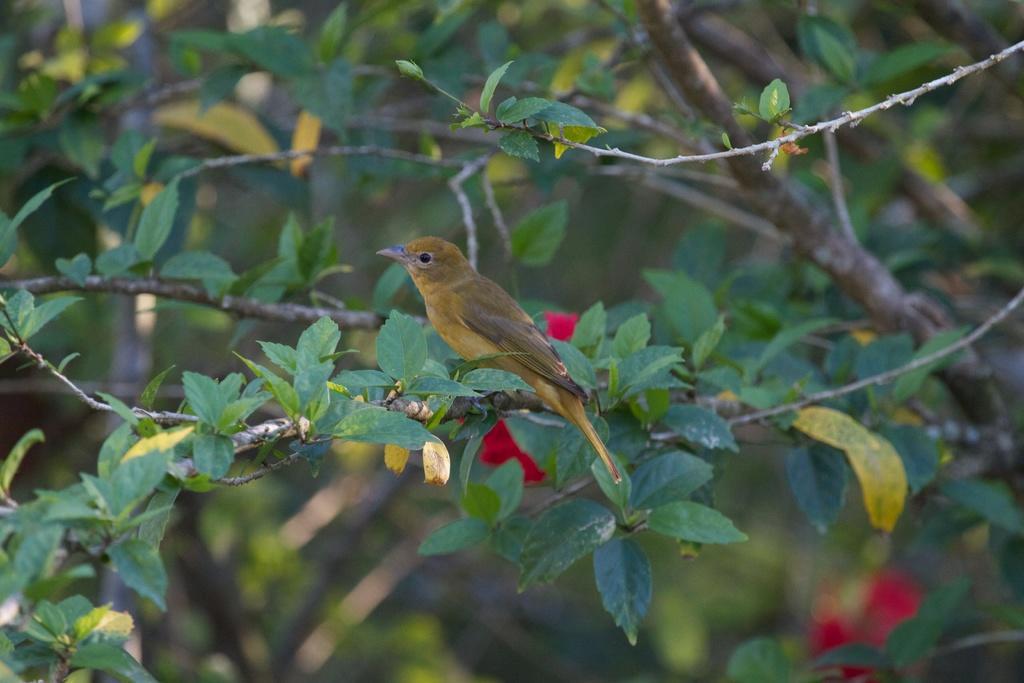Could you give a brief overview of what you see in this image? In the center of the image we can see branches with leaves. On one of the branches, we can see one bird. In the background, we can see it is blurred. 